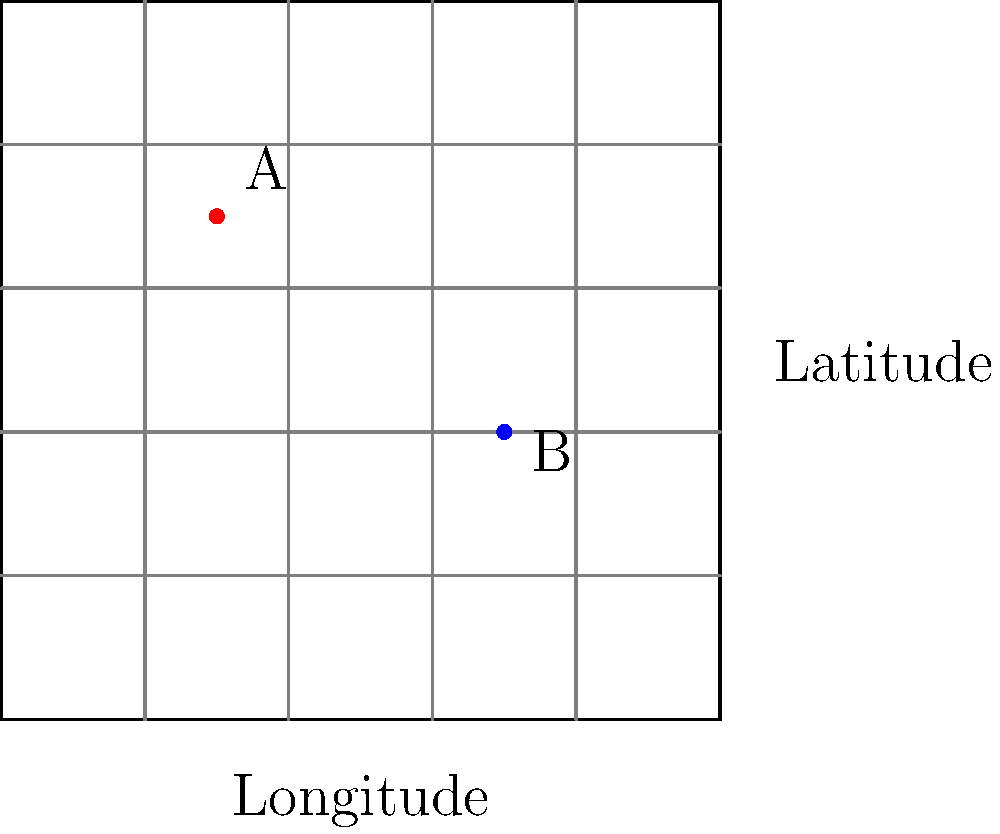Given the map above with a geographic coordinate system, implement a function in PHP that calculates the distance between two points (A and B) using the Haversine formula. Then, explain how you would use a web mapping library like Leaflet.js to display these points on an interactive map. To solve this problem, we'll follow these steps:

1. Implement the Haversine formula in PHP:
   The Haversine formula calculates the great-circle distance between two points on a sphere given their longitudes and latitudes. Here's a PHP function to do this:

   ```php
   function calculateDistance($lat1, $lon1, $lat2, $lon2) {
       $earthRadius = 6371; // in kilometers
       $dLat = deg2rad($lat2 - $lat1);
       $dLon = deg2rad($lon2 - $lon1);
       $a = sin($dLat/2) * sin($dLat/2) +
            cos(deg2rad($lat1)) * cos(deg2rad($lat2)) *
            sin($dLon/2) * sin($dLon/2);
       $c = 2 * atan2(sqrt($a), sqrt(1-$a));
       $distance = $earthRadius * $c;
       return $distance;
   }
   ```

2. Use the function to calculate the distance:
   ```php
   $distanceAB = calculateDistance(70, 30, 40, 70);
   echo "Distance between A and B: " . round($distanceAB, 2) . " km";
   ```

3. Implement a web page with Leaflet.js:
   First, include Leaflet.js and its CSS in your HTML:

   ```html
   <link rel="stylesheet" href="https://unpkg.com/leaflet@1.7.1/dist/leaflet.css" />
   <script src="https://unpkg.com/leaflet@1.7.1/dist/leaflet.js"></script>
   ```

4. Create a div for the map:
   ```html
   <div id="map" style="height: 400px;"></div>
   ```

5. Initialize the map and add markers using JavaScript:
   ```javascript
   var map = L.map('map').setView([55, 50], 4);
   L.tileLayer('https://{s}.tile.openstreetmap.org/{z}/{x}/{y}.png').addTo(map);

   var markerA = L.marker([70, 30]).addTo(map);
   var markerB = L.marker([40, 70]).addTo(map);

   markerA.bindPopup("Point A");
   markerB.bindPopup("Point B");
   ```

6. Display the distance on the map:
   ```javascript
   var distanceAB = <?php echo $distanceAB; ?>;
   var midpoint = [(70 + 40)/2, (30 + 70)/2];
   L.marker(midpoint).addTo(map)
    .bindPopup("Distance: " + distanceAB.toFixed(2) + " km")
    .openPopup();
   ```

This implementation combines PHP for server-side calculations with JavaScript and Leaflet.js for client-side map display and interaction.
Answer: Implement Haversine formula in PHP, use Leaflet.js to display points and distance on interactive map. 